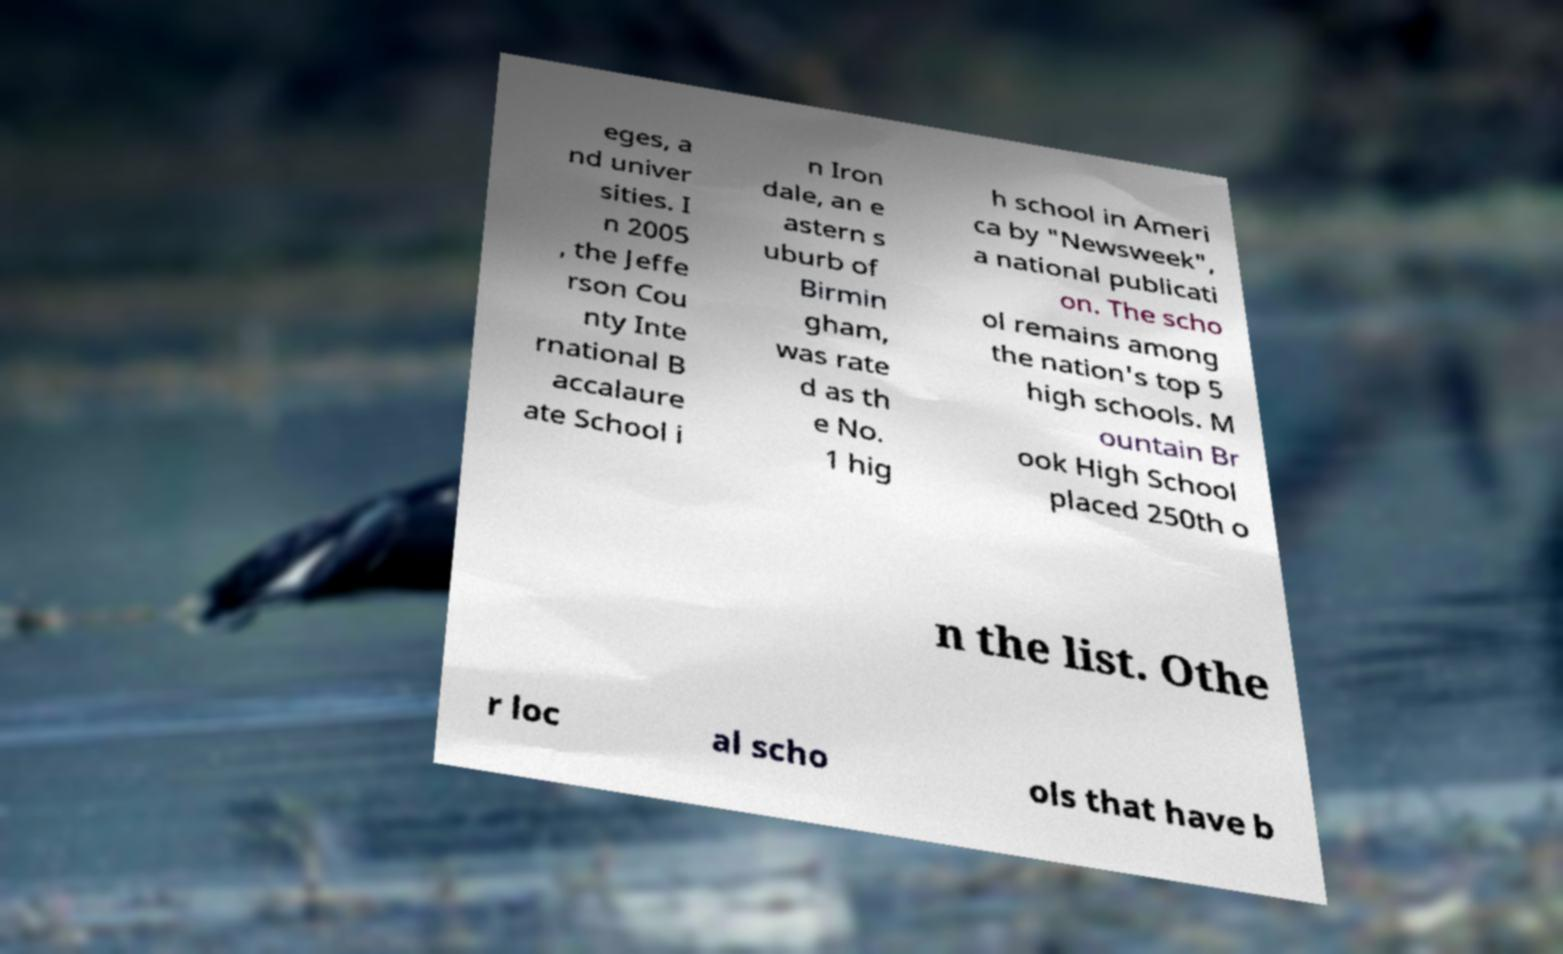There's text embedded in this image that I need extracted. Can you transcribe it verbatim? eges, a nd univer sities. I n 2005 , the Jeffe rson Cou nty Inte rnational B accalaure ate School i n Iron dale, an e astern s uburb of Birmin gham, was rate d as th e No. 1 hig h school in Ameri ca by "Newsweek", a national publicati on. The scho ol remains among the nation's top 5 high schools. M ountain Br ook High School placed 250th o n the list. Othe r loc al scho ols that have b 